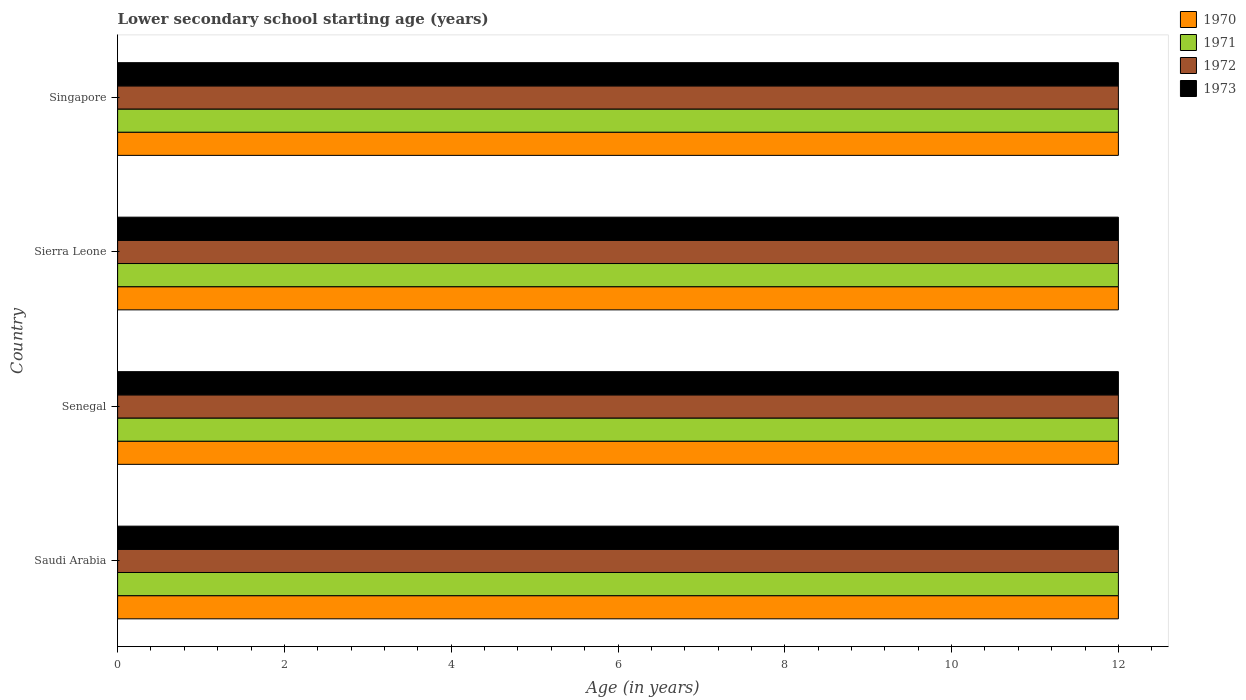How many different coloured bars are there?
Provide a short and direct response. 4. How many groups of bars are there?
Make the answer very short. 4. What is the label of the 4th group of bars from the top?
Make the answer very short. Saudi Arabia. In how many cases, is the number of bars for a given country not equal to the number of legend labels?
Provide a short and direct response. 0. What is the lower secondary school starting age of children in 1970 in Sierra Leone?
Provide a short and direct response. 12. Across all countries, what is the maximum lower secondary school starting age of children in 1971?
Your response must be concise. 12. Across all countries, what is the minimum lower secondary school starting age of children in 1972?
Make the answer very short. 12. In which country was the lower secondary school starting age of children in 1972 maximum?
Your response must be concise. Saudi Arabia. In which country was the lower secondary school starting age of children in 1970 minimum?
Offer a terse response. Saudi Arabia. What is the total lower secondary school starting age of children in 1970 in the graph?
Provide a short and direct response. 48. What is the difference between the lower secondary school starting age of children in 1973 in Sierra Leone and that in Singapore?
Offer a terse response. 0. What is the average lower secondary school starting age of children in 1971 per country?
Provide a short and direct response. 12. What is the difference between the lower secondary school starting age of children in 1970 and lower secondary school starting age of children in 1971 in Senegal?
Keep it short and to the point. 0. Is the difference between the lower secondary school starting age of children in 1970 in Senegal and Singapore greater than the difference between the lower secondary school starting age of children in 1971 in Senegal and Singapore?
Offer a very short reply. No. Is the sum of the lower secondary school starting age of children in 1971 in Senegal and Sierra Leone greater than the maximum lower secondary school starting age of children in 1973 across all countries?
Offer a very short reply. Yes. Is it the case that in every country, the sum of the lower secondary school starting age of children in 1972 and lower secondary school starting age of children in 1971 is greater than the sum of lower secondary school starting age of children in 1973 and lower secondary school starting age of children in 1970?
Give a very brief answer. No. What is the difference between two consecutive major ticks on the X-axis?
Your answer should be compact. 2. Does the graph contain grids?
Your answer should be very brief. No. What is the title of the graph?
Provide a succinct answer. Lower secondary school starting age (years). What is the label or title of the X-axis?
Offer a very short reply. Age (in years). What is the label or title of the Y-axis?
Provide a short and direct response. Country. What is the Age (in years) in 1970 in Senegal?
Make the answer very short. 12. What is the Age (in years) in 1973 in Senegal?
Offer a terse response. 12. What is the Age (in years) in 1971 in Sierra Leone?
Provide a short and direct response. 12. What is the Age (in years) of 1973 in Sierra Leone?
Your response must be concise. 12. What is the Age (in years) in 1972 in Singapore?
Provide a succinct answer. 12. What is the Age (in years) of 1973 in Singapore?
Make the answer very short. 12. Across all countries, what is the maximum Age (in years) in 1970?
Offer a very short reply. 12. Across all countries, what is the maximum Age (in years) in 1971?
Provide a succinct answer. 12. Across all countries, what is the maximum Age (in years) in 1972?
Make the answer very short. 12. Across all countries, what is the maximum Age (in years) in 1973?
Your answer should be very brief. 12. Across all countries, what is the minimum Age (in years) in 1971?
Keep it short and to the point. 12. Across all countries, what is the minimum Age (in years) of 1972?
Offer a very short reply. 12. Across all countries, what is the minimum Age (in years) in 1973?
Your answer should be very brief. 12. What is the total Age (in years) in 1971 in the graph?
Your answer should be very brief. 48. What is the difference between the Age (in years) of 1970 in Saudi Arabia and that in Senegal?
Your answer should be compact. 0. What is the difference between the Age (in years) in 1972 in Saudi Arabia and that in Senegal?
Keep it short and to the point. 0. What is the difference between the Age (in years) of 1973 in Saudi Arabia and that in Senegal?
Your response must be concise. 0. What is the difference between the Age (in years) in 1970 in Saudi Arabia and that in Sierra Leone?
Ensure brevity in your answer.  0. What is the difference between the Age (in years) of 1971 in Saudi Arabia and that in Sierra Leone?
Offer a very short reply. 0. What is the difference between the Age (in years) of 1971 in Saudi Arabia and that in Singapore?
Your answer should be compact. 0. What is the difference between the Age (in years) of 1973 in Saudi Arabia and that in Singapore?
Provide a succinct answer. 0. What is the difference between the Age (in years) of 1970 in Senegal and that in Sierra Leone?
Your answer should be compact. 0. What is the difference between the Age (in years) in 1973 in Senegal and that in Sierra Leone?
Offer a terse response. 0. What is the difference between the Age (in years) of 1972 in Senegal and that in Singapore?
Your response must be concise. 0. What is the difference between the Age (in years) of 1971 in Sierra Leone and that in Singapore?
Offer a terse response. 0. What is the difference between the Age (in years) of 1972 in Sierra Leone and that in Singapore?
Keep it short and to the point. 0. What is the difference between the Age (in years) of 1973 in Sierra Leone and that in Singapore?
Your answer should be compact. 0. What is the difference between the Age (in years) in 1970 in Saudi Arabia and the Age (in years) in 1971 in Senegal?
Your answer should be very brief. 0. What is the difference between the Age (in years) in 1970 in Saudi Arabia and the Age (in years) in 1972 in Senegal?
Provide a short and direct response. 0. What is the difference between the Age (in years) of 1972 in Saudi Arabia and the Age (in years) of 1973 in Senegal?
Make the answer very short. 0. What is the difference between the Age (in years) of 1970 in Saudi Arabia and the Age (in years) of 1972 in Sierra Leone?
Provide a short and direct response. 0. What is the difference between the Age (in years) in 1970 in Saudi Arabia and the Age (in years) in 1973 in Sierra Leone?
Your response must be concise. 0. What is the difference between the Age (in years) of 1971 in Saudi Arabia and the Age (in years) of 1972 in Sierra Leone?
Your answer should be very brief. 0. What is the difference between the Age (in years) of 1970 in Saudi Arabia and the Age (in years) of 1971 in Singapore?
Offer a terse response. 0. What is the difference between the Age (in years) of 1970 in Saudi Arabia and the Age (in years) of 1972 in Singapore?
Provide a succinct answer. 0. What is the difference between the Age (in years) in 1970 in Saudi Arabia and the Age (in years) in 1973 in Singapore?
Your answer should be very brief. 0. What is the difference between the Age (in years) of 1971 in Saudi Arabia and the Age (in years) of 1973 in Singapore?
Your answer should be compact. 0. What is the difference between the Age (in years) of 1970 in Senegal and the Age (in years) of 1971 in Sierra Leone?
Ensure brevity in your answer.  0. What is the difference between the Age (in years) of 1970 in Senegal and the Age (in years) of 1972 in Sierra Leone?
Your answer should be very brief. 0. What is the difference between the Age (in years) of 1971 in Senegal and the Age (in years) of 1972 in Sierra Leone?
Offer a very short reply. 0. What is the difference between the Age (in years) of 1971 in Senegal and the Age (in years) of 1973 in Sierra Leone?
Give a very brief answer. 0. What is the difference between the Age (in years) in 1970 in Senegal and the Age (in years) in 1973 in Singapore?
Provide a succinct answer. 0. What is the difference between the Age (in years) of 1971 in Senegal and the Age (in years) of 1972 in Singapore?
Offer a terse response. 0. What is the difference between the Age (in years) of 1971 in Senegal and the Age (in years) of 1973 in Singapore?
Offer a terse response. 0. What is the difference between the Age (in years) in 1970 in Sierra Leone and the Age (in years) in 1972 in Singapore?
Keep it short and to the point. 0. What is the difference between the Age (in years) of 1970 in Sierra Leone and the Age (in years) of 1973 in Singapore?
Offer a terse response. 0. What is the difference between the Age (in years) in 1971 in Sierra Leone and the Age (in years) in 1973 in Singapore?
Your answer should be compact. 0. What is the difference between the Age (in years) in 1972 in Sierra Leone and the Age (in years) in 1973 in Singapore?
Your answer should be very brief. 0. What is the average Age (in years) of 1971 per country?
Provide a succinct answer. 12. What is the difference between the Age (in years) in 1970 and Age (in years) in 1971 in Saudi Arabia?
Offer a terse response. 0. What is the difference between the Age (in years) of 1970 and Age (in years) of 1972 in Saudi Arabia?
Offer a very short reply. 0. What is the difference between the Age (in years) in 1972 and Age (in years) in 1973 in Saudi Arabia?
Make the answer very short. 0. What is the difference between the Age (in years) of 1970 and Age (in years) of 1971 in Senegal?
Keep it short and to the point. 0. What is the difference between the Age (in years) in 1970 and Age (in years) in 1972 in Senegal?
Ensure brevity in your answer.  0. What is the difference between the Age (in years) of 1970 and Age (in years) of 1973 in Senegal?
Offer a very short reply. 0. What is the difference between the Age (in years) of 1971 and Age (in years) of 1972 in Senegal?
Provide a succinct answer. 0. What is the difference between the Age (in years) in 1971 and Age (in years) in 1973 in Senegal?
Your answer should be compact. 0. What is the difference between the Age (in years) of 1972 and Age (in years) of 1973 in Senegal?
Make the answer very short. 0. What is the difference between the Age (in years) in 1970 and Age (in years) in 1972 in Sierra Leone?
Offer a very short reply. 0. What is the difference between the Age (in years) of 1971 and Age (in years) of 1972 in Sierra Leone?
Your answer should be very brief. 0. What is the difference between the Age (in years) of 1970 and Age (in years) of 1973 in Singapore?
Keep it short and to the point. 0. What is the difference between the Age (in years) in 1971 and Age (in years) in 1972 in Singapore?
Provide a short and direct response. 0. What is the difference between the Age (in years) of 1971 and Age (in years) of 1973 in Singapore?
Your answer should be compact. 0. What is the difference between the Age (in years) in 1972 and Age (in years) in 1973 in Singapore?
Your answer should be very brief. 0. What is the ratio of the Age (in years) of 1970 in Saudi Arabia to that in Senegal?
Offer a very short reply. 1. What is the ratio of the Age (in years) of 1970 in Saudi Arabia to that in Sierra Leone?
Give a very brief answer. 1. What is the ratio of the Age (in years) of 1973 in Saudi Arabia to that in Sierra Leone?
Your response must be concise. 1. What is the ratio of the Age (in years) of 1970 in Saudi Arabia to that in Singapore?
Keep it short and to the point. 1. What is the ratio of the Age (in years) in 1971 in Saudi Arabia to that in Singapore?
Offer a very short reply. 1. What is the ratio of the Age (in years) of 1971 in Senegal to that in Sierra Leone?
Provide a short and direct response. 1. What is the ratio of the Age (in years) of 1970 in Senegal to that in Singapore?
Your answer should be compact. 1. What is the ratio of the Age (in years) of 1970 in Sierra Leone to that in Singapore?
Provide a short and direct response. 1. What is the ratio of the Age (in years) of 1972 in Sierra Leone to that in Singapore?
Your answer should be compact. 1. What is the ratio of the Age (in years) in 1973 in Sierra Leone to that in Singapore?
Ensure brevity in your answer.  1. What is the difference between the highest and the second highest Age (in years) of 1970?
Offer a very short reply. 0. What is the difference between the highest and the second highest Age (in years) in 1971?
Offer a very short reply. 0. What is the difference between the highest and the second highest Age (in years) of 1972?
Make the answer very short. 0. What is the difference between the highest and the lowest Age (in years) of 1971?
Your answer should be very brief. 0. What is the difference between the highest and the lowest Age (in years) of 1972?
Give a very brief answer. 0. 